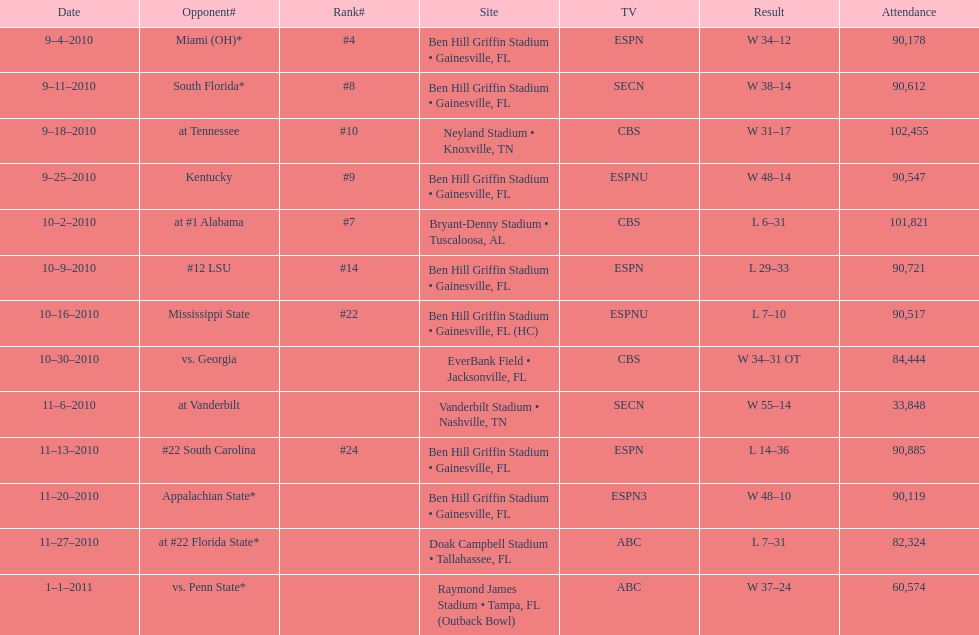During the 2010-2011 season, what was the total number of games held at ben hill griffin stadium? 7. 